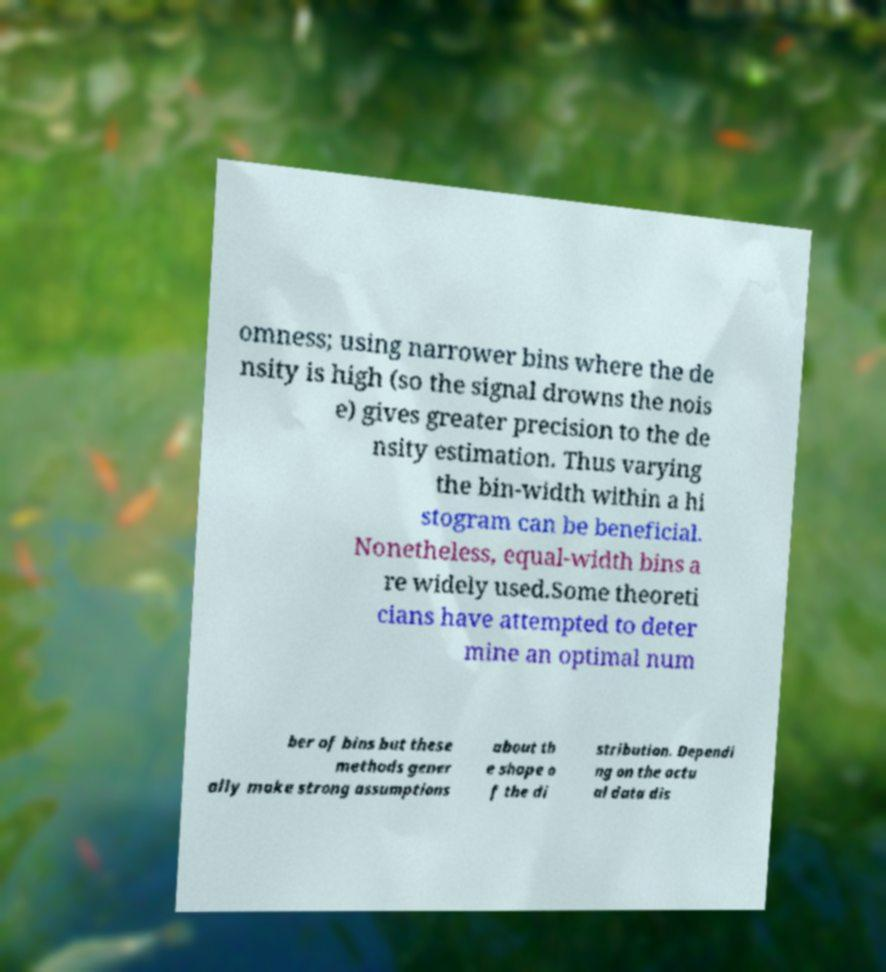Can you read and provide the text displayed in the image?This photo seems to have some interesting text. Can you extract and type it out for me? omness; using narrower bins where the de nsity is high (so the signal drowns the nois e) gives greater precision to the de nsity estimation. Thus varying the bin-width within a hi stogram can be beneficial. Nonetheless, equal-width bins a re widely used.Some theoreti cians have attempted to deter mine an optimal num ber of bins but these methods gener ally make strong assumptions about th e shape o f the di stribution. Dependi ng on the actu al data dis 